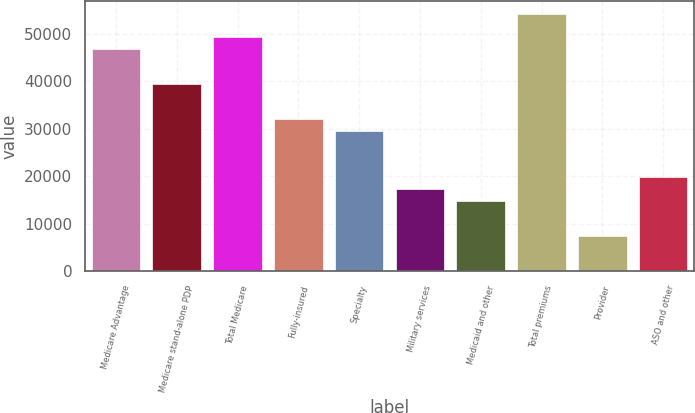<chart> <loc_0><loc_0><loc_500><loc_500><bar_chart><fcel>Medicare Advantage<fcel>Medicare stand-alone PDP<fcel>Total Medicare<fcel>Fully-insured<fcel>Specialty<fcel>Military services<fcel>Medicaid and other<fcel>Total premiums<fcel>Provider<fcel>ASO and other<nl><fcel>46843<fcel>39447<fcel>49308.3<fcel>32051<fcel>29585.7<fcel>17259<fcel>14793.7<fcel>54239<fcel>7397.65<fcel>19724.3<nl></chart> 